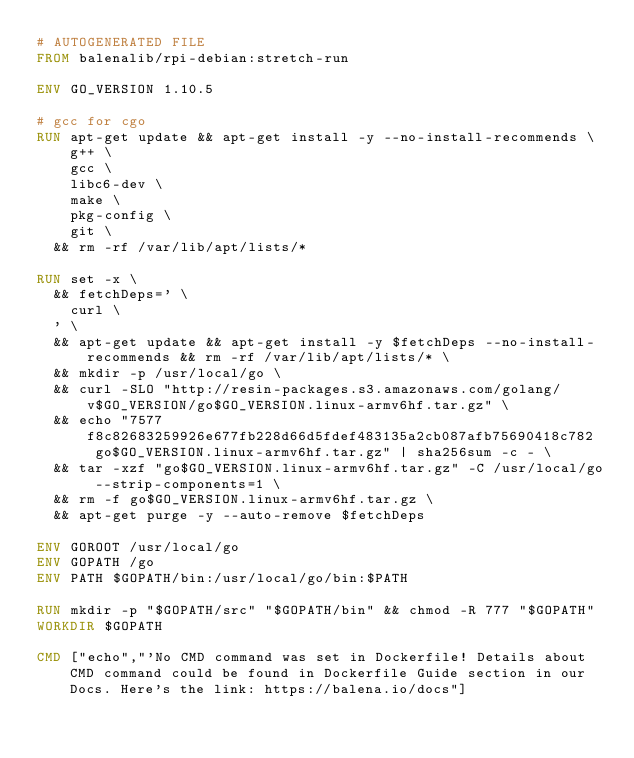Convert code to text. <code><loc_0><loc_0><loc_500><loc_500><_Dockerfile_># AUTOGENERATED FILE
FROM balenalib/rpi-debian:stretch-run

ENV GO_VERSION 1.10.5

# gcc for cgo
RUN apt-get update && apt-get install -y --no-install-recommends \
		g++ \
		gcc \
		libc6-dev \
		make \
		pkg-config \
		git \
	&& rm -rf /var/lib/apt/lists/*

RUN set -x \
	&& fetchDeps=' \
		curl \
	' \
	&& apt-get update && apt-get install -y $fetchDeps --no-install-recommends && rm -rf /var/lib/apt/lists/* \
	&& mkdir -p /usr/local/go \
	&& curl -SLO "http://resin-packages.s3.amazonaws.com/golang/v$GO_VERSION/go$GO_VERSION.linux-armv6hf.tar.gz" \
	&& echo "7577f8c82683259926e677fb228d66d5fdef483135a2cb087afb75690418c782  go$GO_VERSION.linux-armv6hf.tar.gz" | sha256sum -c - \
	&& tar -xzf "go$GO_VERSION.linux-armv6hf.tar.gz" -C /usr/local/go --strip-components=1 \
	&& rm -f go$GO_VERSION.linux-armv6hf.tar.gz \
	&& apt-get purge -y --auto-remove $fetchDeps

ENV GOROOT /usr/local/go
ENV GOPATH /go
ENV PATH $GOPATH/bin:/usr/local/go/bin:$PATH

RUN mkdir -p "$GOPATH/src" "$GOPATH/bin" && chmod -R 777 "$GOPATH"
WORKDIR $GOPATH

CMD ["echo","'No CMD command was set in Dockerfile! Details about CMD command could be found in Dockerfile Guide section in our Docs. Here's the link: https://balena.io/docs"]</code> 